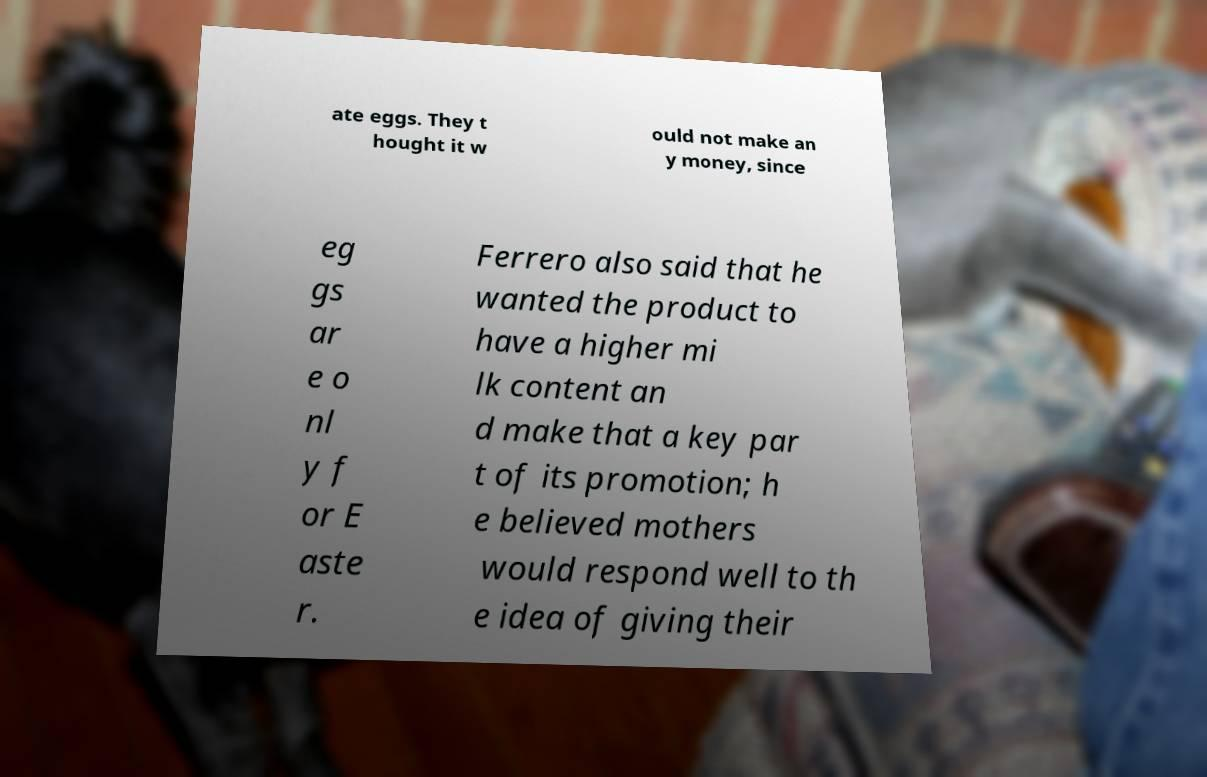For documentation purposes, I need the text within this image transcribed. Could you provide that? ate eggs. They t hought it w ould not make an y money, since eg gs ar e o nl y f or E aste r. Ferrero also said that he wanted the product to have a higher mi lk content an d make that a key par t of its promotion; h e believed mothers would respond well to th e idea of giving their 